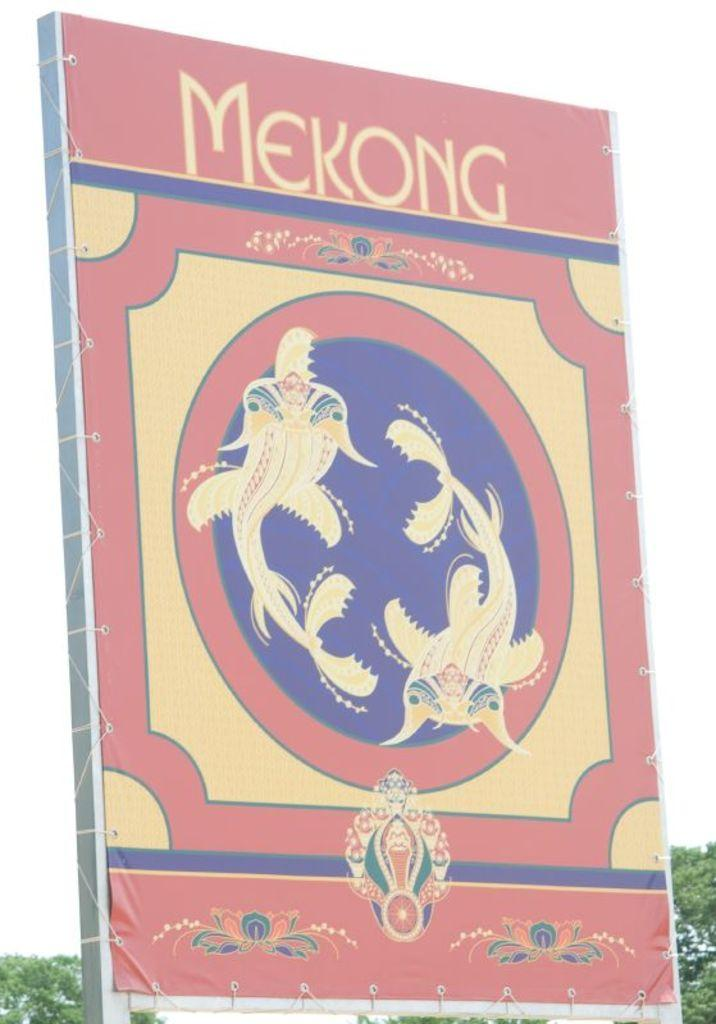<image>
Describe the image concisely. A picture of a colorful book with the title Mekong 